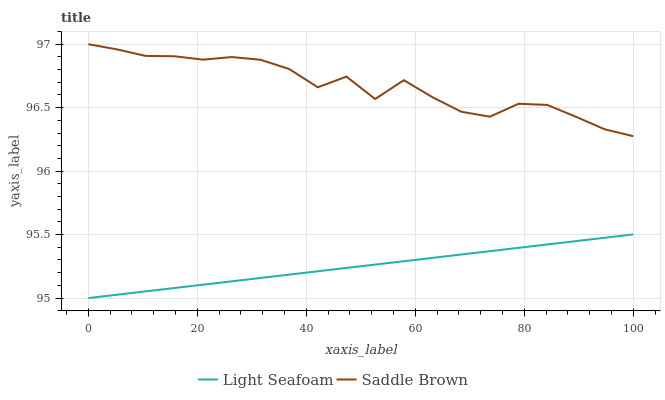Does Light Seafoam have the minimum area under the curve?
Answer yes or no. Yes. Does Saddle Brown have the minimum area under the curve?
Answer yes or no. No. Is Saddle Brown the smoothest?
Answer yes or no. No. Does Saddle Brown have the lowest value?
Answer yes or no. No. Is Light Seafoam less than Saddle Brown?
Answer yes or no. Yes. Is Saddle Brown greater than Light Seafoam?
Answer yes or no. Yes. Does Light Seafoam intersect Saddle Brown?
Answer yes or no. No. 